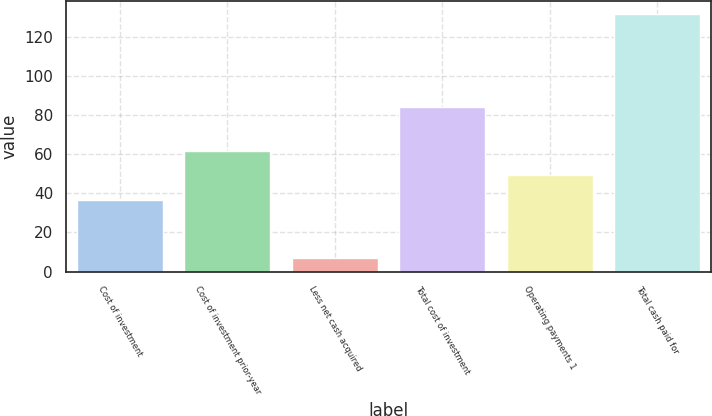<chart> <loc_0><loc_0><loc_500><loc_500><bar_chart><fcel>Cost of investment<fcel>Cost of investment prior-year<fcel>Less net cash acquired<fcel>Total cost of investment<fcel>Operating payments 1<fcel>Total cash paid for<nl><fcel>36.8<fcel>61.66<fcel>7.1<fcel>84.3<fcel>49.23<fcel>131.4<nl></chart> 